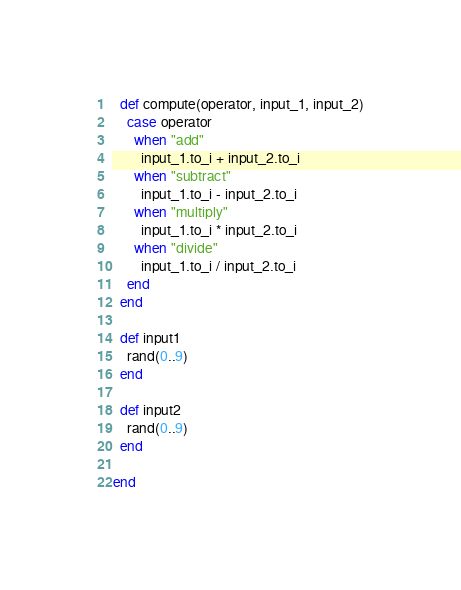Convert code to text. <code><loc_0><loc_0><loc_500><loc_500><_Ruby_>  def compute(operator, input_1, input_2)
    case operator
      when "add"
        input_1.to_i + input_2.to_i
      when "subtract"
        input_1.to_i - input_2.to_i
      when "multiply"
        input_1.to_i * input_2.to_i
      when "divide"
        input_1.to_i / input_2.to_i
    end
  end
  
  def input1
    rand(0..9)
  end
  
  def input2
    rand(0..9)
  end
  
end</code> 